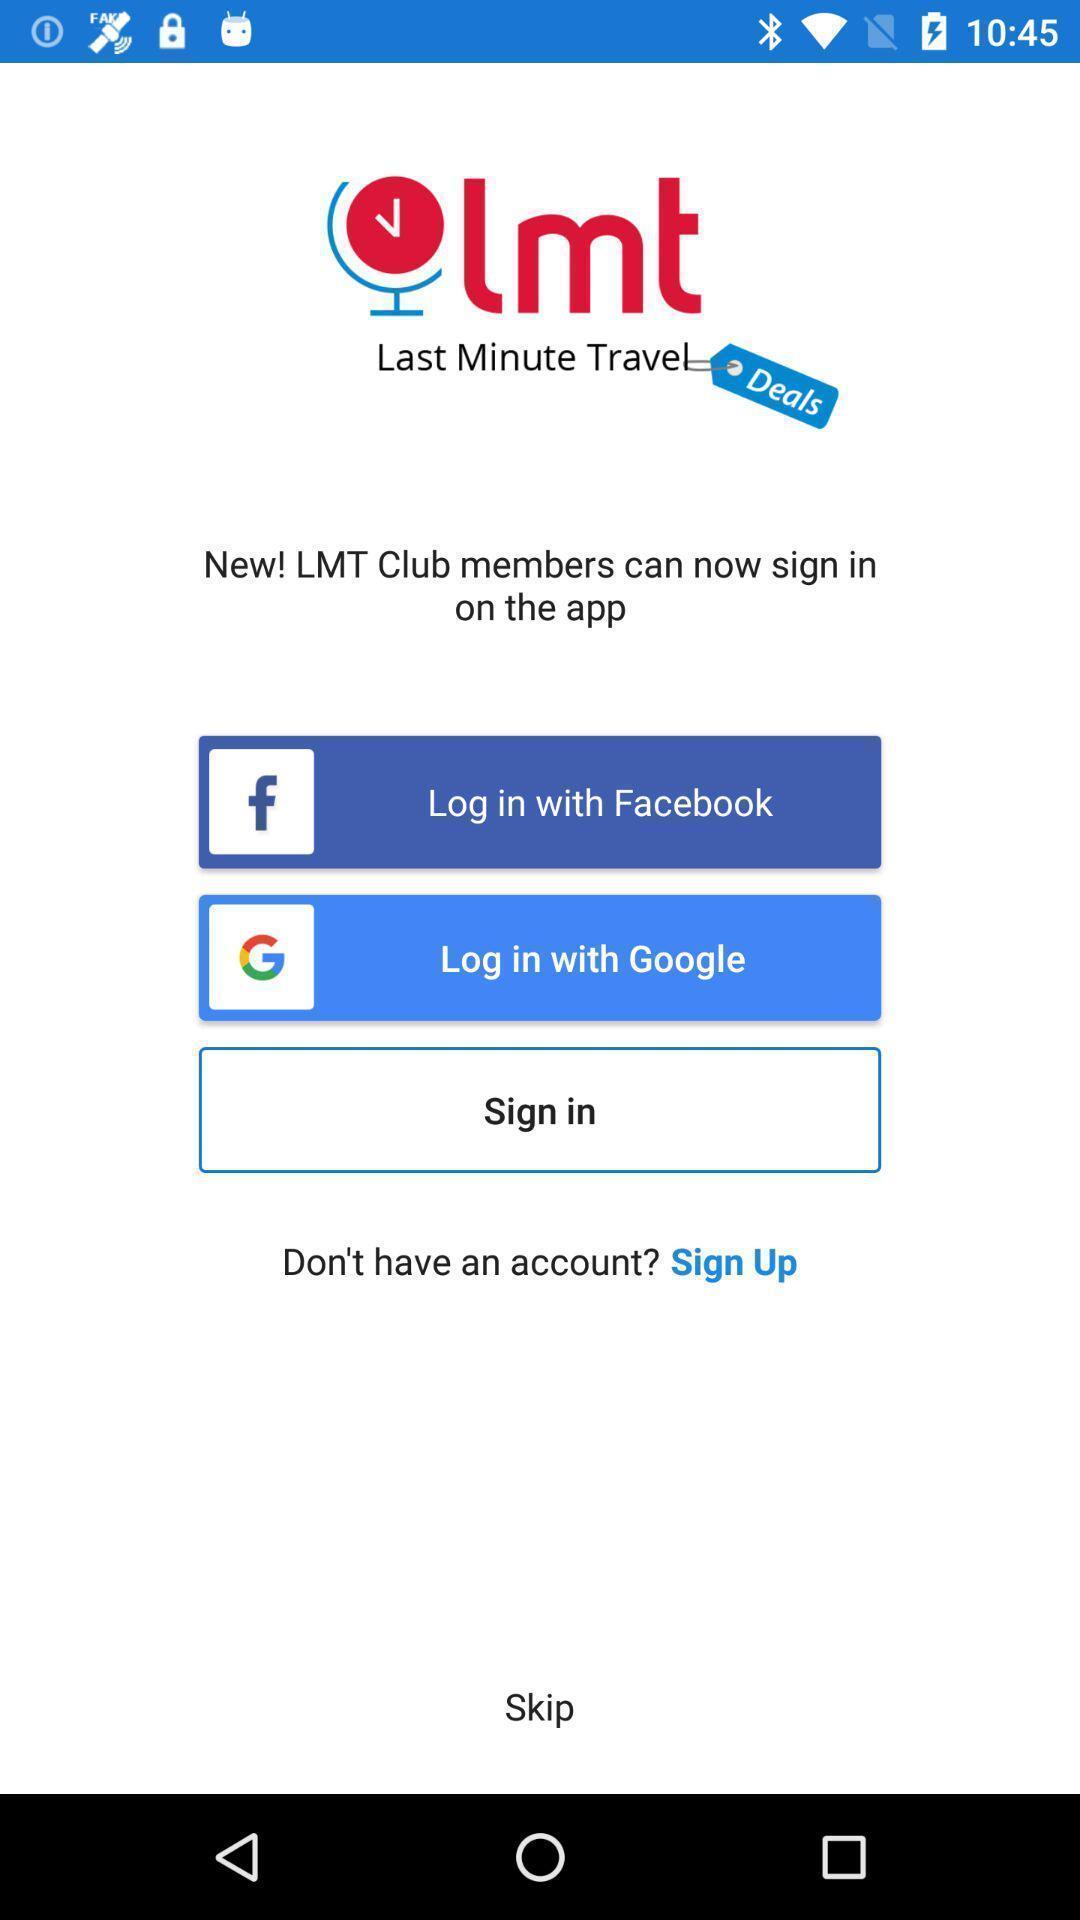Give me a summary of this screen capture. Welcome page of an online booking app. 